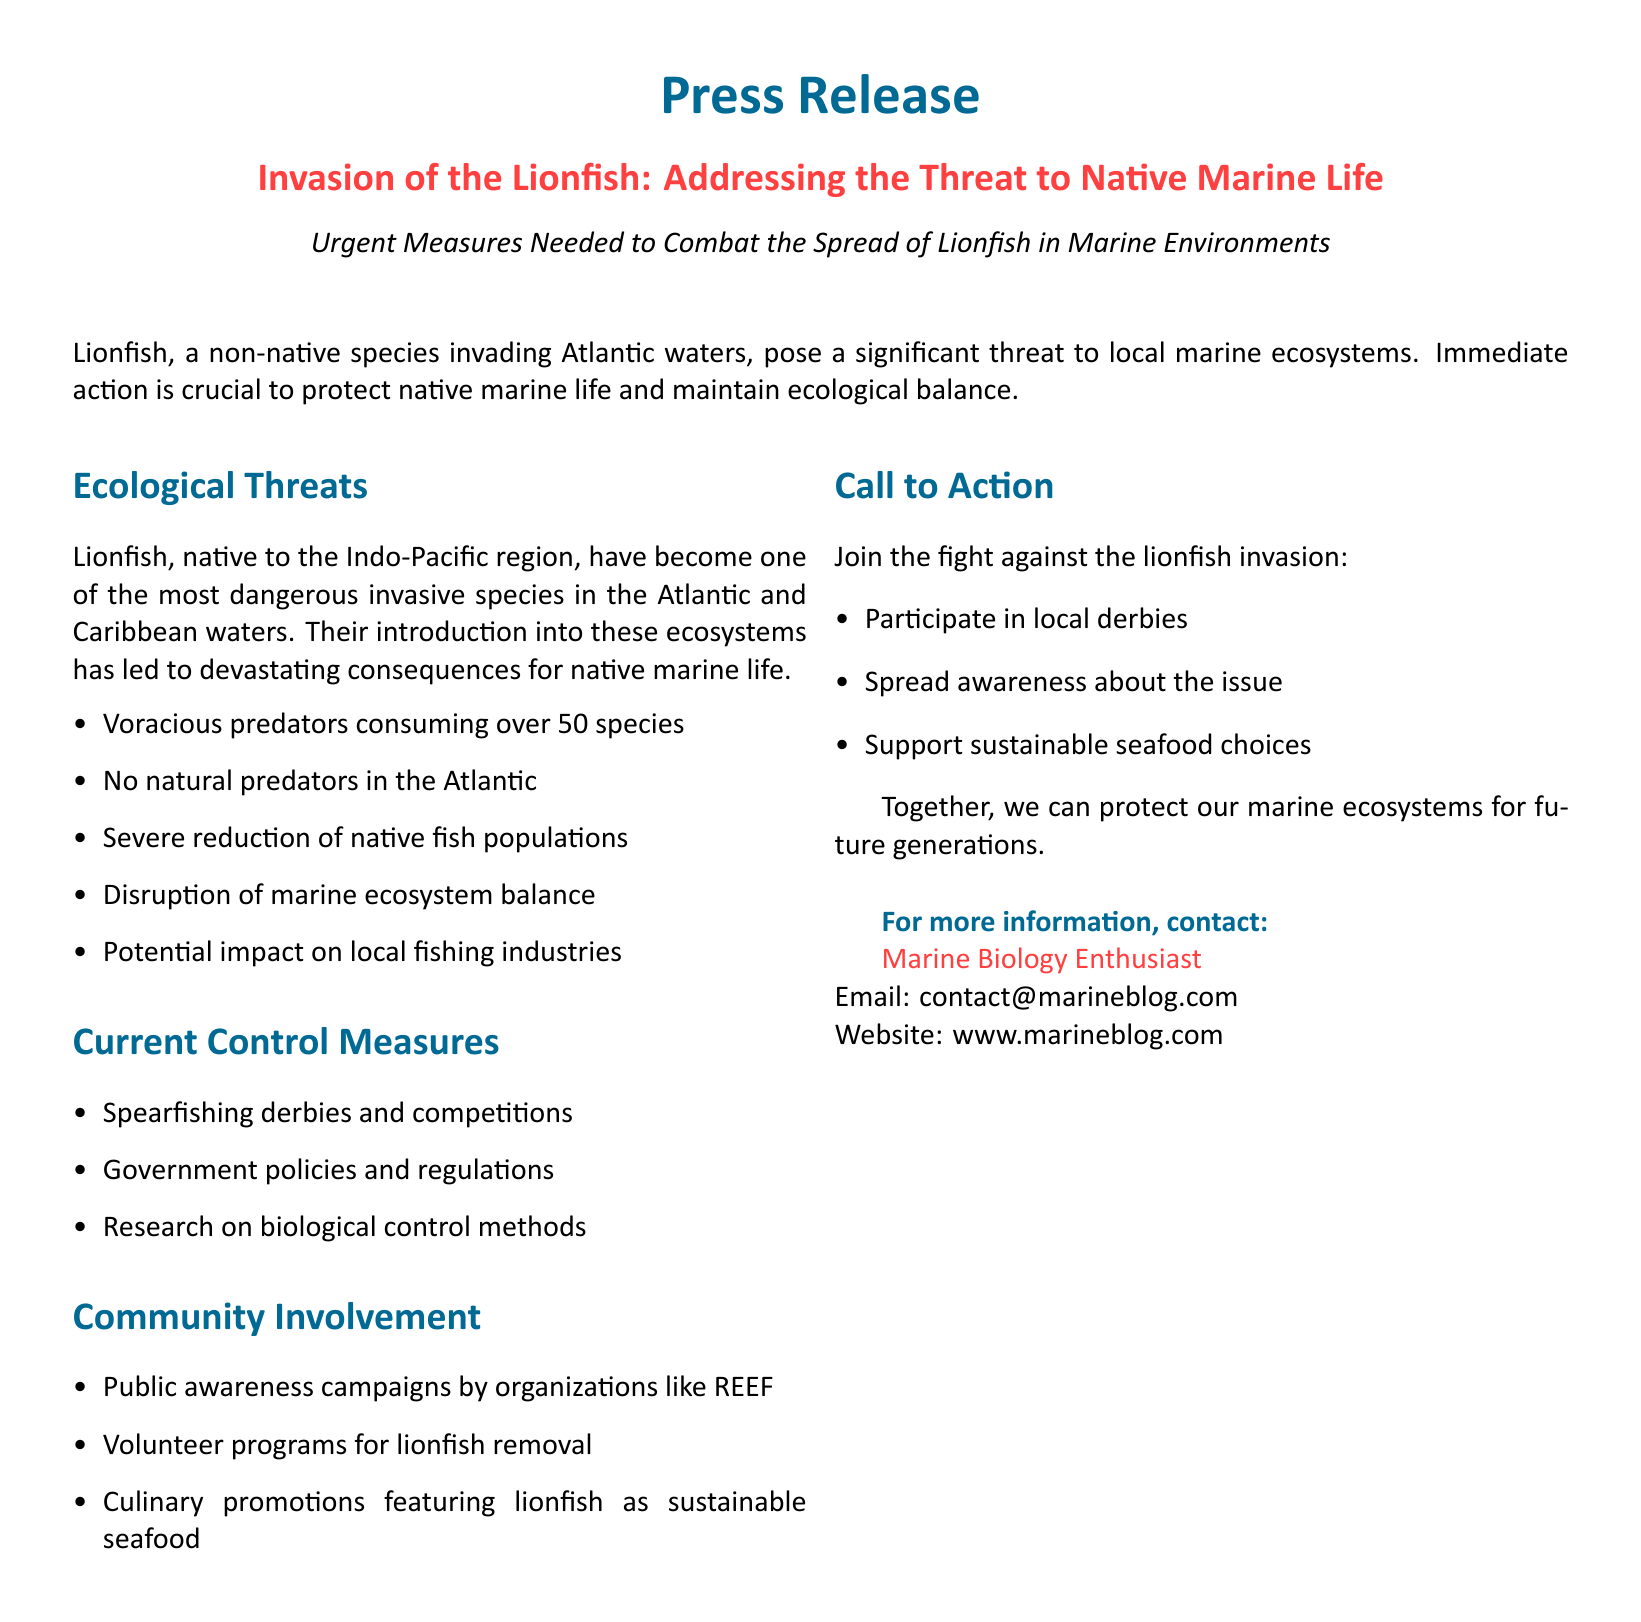What is the name of the invasive species addressed in the press release? The press release focuses on the lionfish, which is identified as an invasive species threatening native marine life.
Answer: lionfish What regions are primarily affected by the lionfish invasion? The document highlights the Atlantic and Caribbean waters as the primary regions impacted by lionfish.
Answer: Atlantic waters and Caribbean waters How many species do lionfish consume? The document states that lionfish are voracious predators, consuming over 50 different fish species.
Answer: over 50 species What is a notable ecological impact of lionfish mentioned in the document? One of the significant ecological impacts mentioned is the severe reduction of native fish populations due to lionfish predation.
Answer: severe reduction of native fish populations What type of events are organized to combat lionfish? The press release mentions that spearfishing derbies and competitions are conducted as part of the current control measures to address lionfish invasion.
Answer: spearfishing derbies and competitions Which organization is mentioned for its public awareness campaigns? The document specifies REEF as an organization that conducts public awareness campaigns concerning the lionfish invasion.
Answer: REEF What is one way the community is invited to participate against the invasion? The call to action in the press release encourages individuals to participate in local derbies as a means of engaging in the fight against lionfish.
Answer: participate in local derbies Who should be contacted for more information? The press release provides contact information for a "Marine Biology Enthusiast" for those seeking further details on the issue.
Answer: Marine Biology Enthusiast 